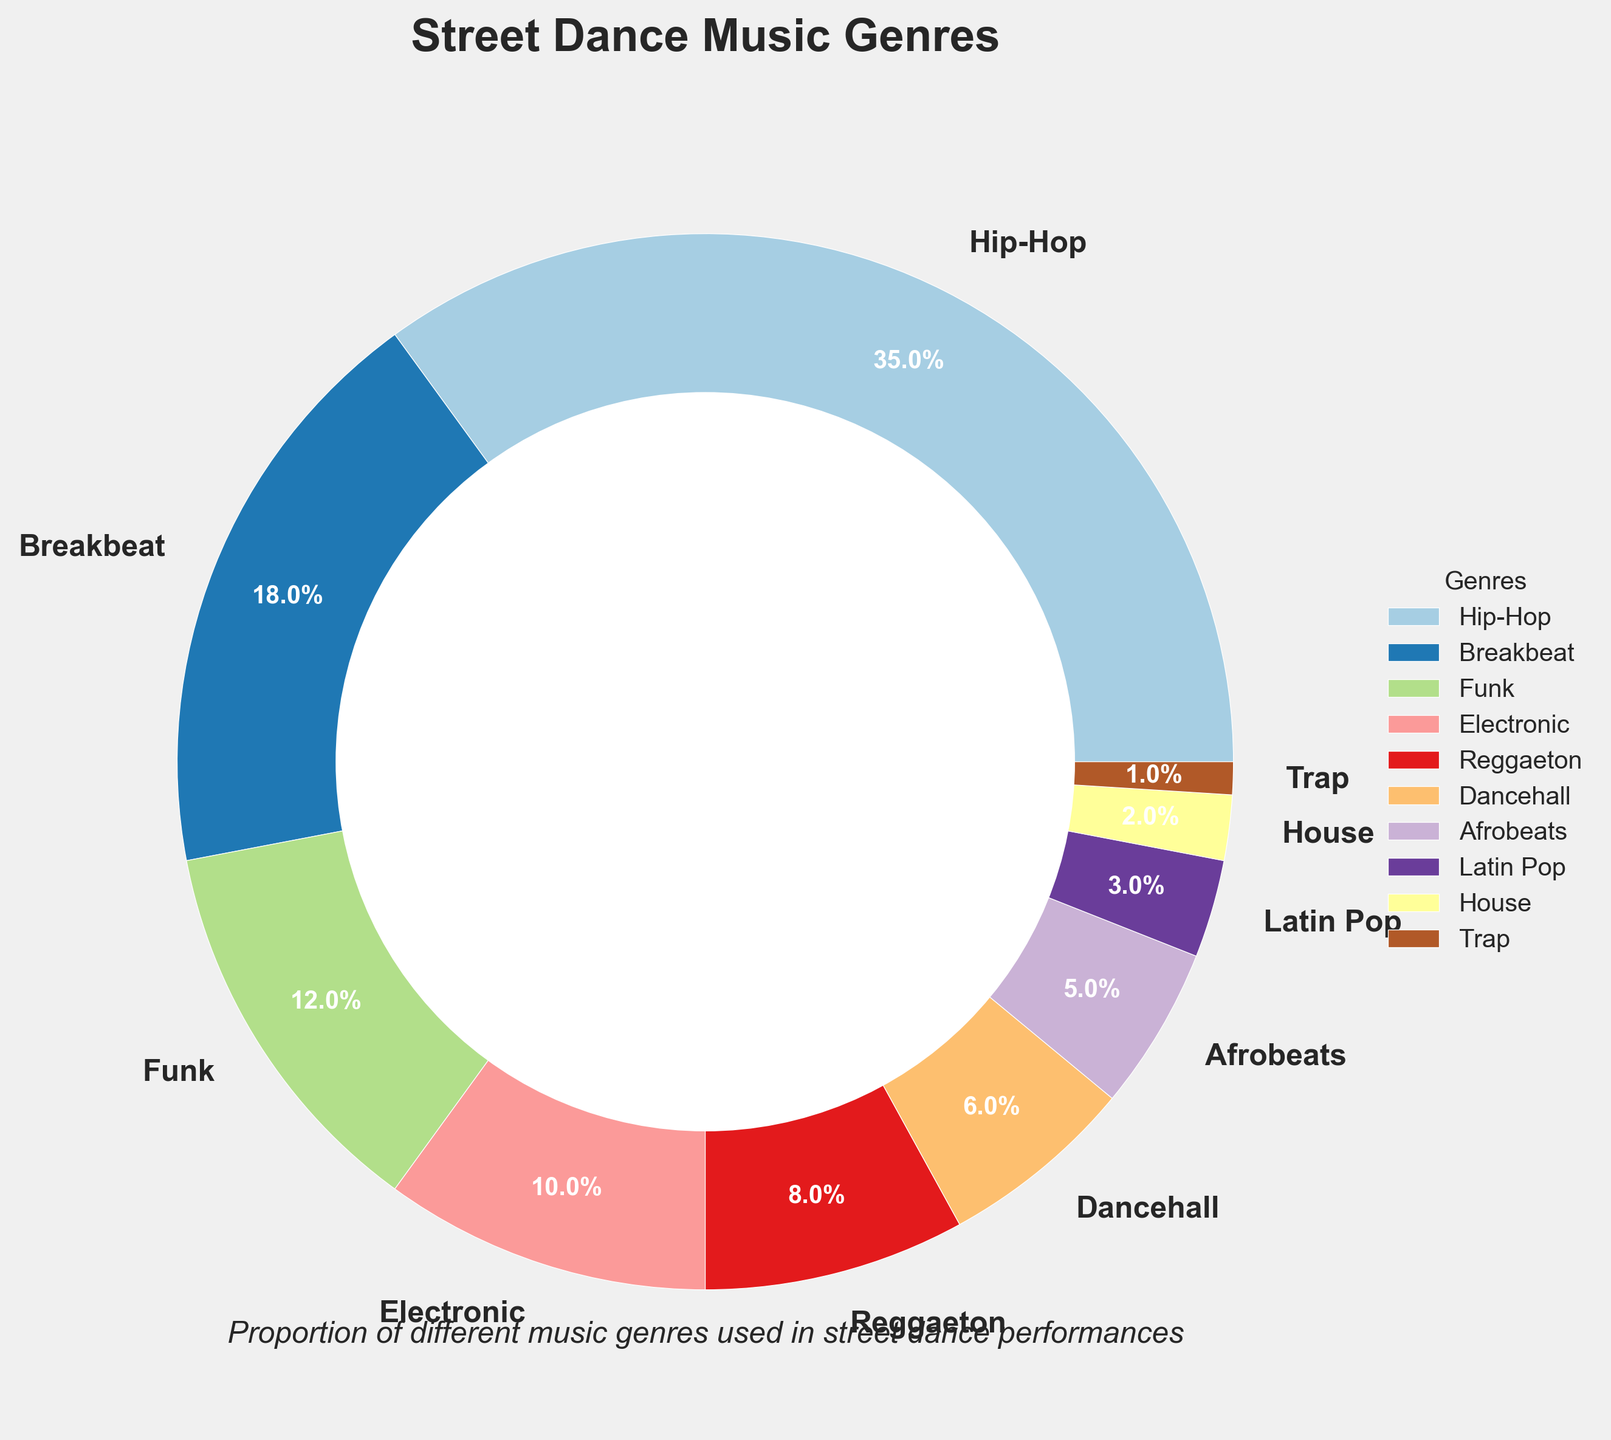What percentage of street dance performances use Hip-Hop and Breakbeat music combined? To find the combined percentage, add the percentages of Hip-Hop and Breakbeat. Hip-Hop is 35% and Breakbeat is 18%. So, 35% + 18% = 53%.
Answer: 53% Which music genre is used least in street dance performances? The pie chart shows the percentages for each genre. The genre with the smallest percentage is Trap, which is 1%.
Answer: Trap How much higher is the percentage of Hip-Hop music compared to Dancehall music? Subtract the percentage of Dancehall from the percentage of Hip-Hop. Hip-Hop is 35% and Dancehall is 6%. So, 35% - 6% = 29%.
Answer: 29% What is the total percentage taken up by Funk, Electronic, and Latin Pop genres? Add the percentages of Funk, Electronic, and Latin Pop. Funk is 12%, Electronic is 10%, and Latin Pop is 3%. So, 12% + 10% + 3% = 25%.
Answer: 25% Which has a higher percentage: Electronic or Reggaeton music? Compare the percentages of Electronic and Reggaeton. Electronic is 10%, while Reggaeton is 8%. 10% is greater than 8%.
Answer: Electronic What is the difference in percentage between the most and least used music genres? Subtract the percentage of the least used genre (Trap: 1%) from the percentage of the most used genre (Hip-Hop: 35%). So, 35% - 1% = 34%.
Answer: 34% Which genre represents approximately one-third of the music used in street dance performances? The pie chart shows that Hip-Hop represents 35%, which is close to one-third (33.33%).
Answer: Hip-Hop How does the usage of Reggaeton compare to Dancehall? The pie chart shows Reggaeton at 8% and Dancehall at 6%. 8% is greater than 6%.
Answer: Reggaeton is higher What fraction of the pie chart is made up by Afrobeats and Latin Pop combined? Add the percentages of Afrobeats and Latin Pop. Afrobeats is 5% and Latin Pop is 3%. So, 5% + 3% = 8%. Since 8% of 100% is 8/100, the fraction is 8/100 or 2/25.
Answer: 2/25 